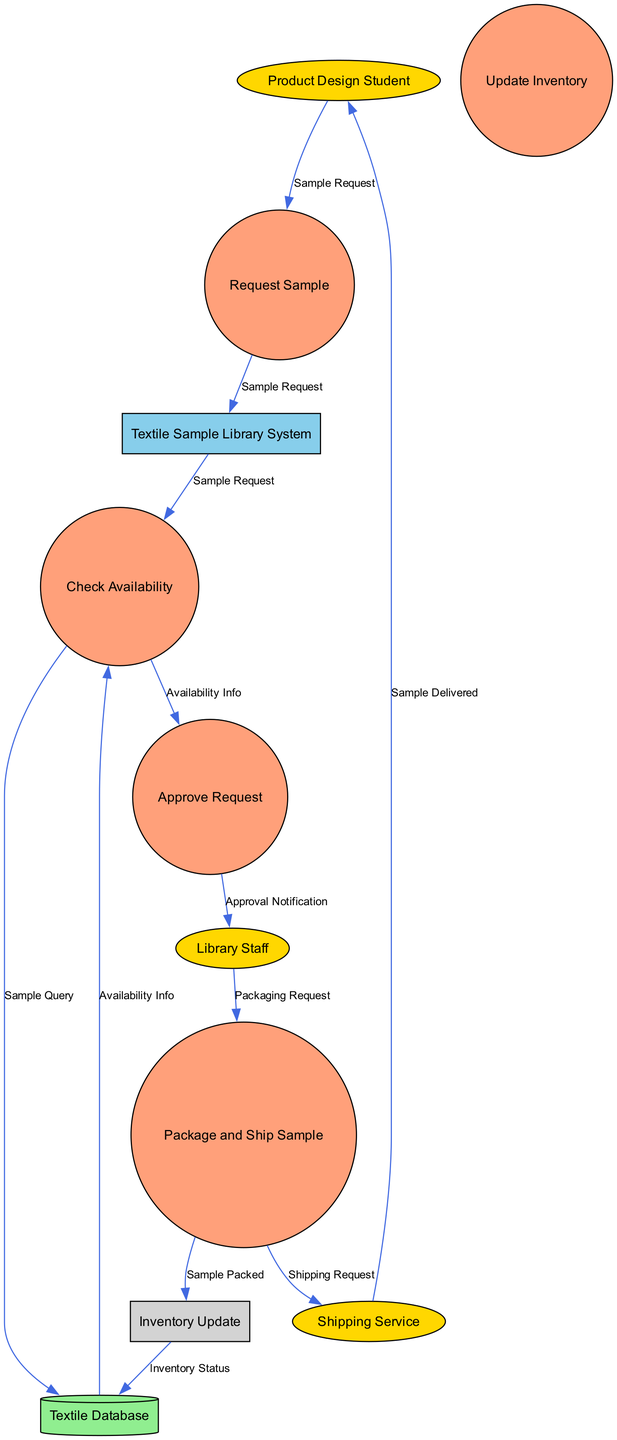What is the name of the system? The system representing the management and processing of textile samples is labeled as "Textile Sample Library System" in the diagram, indicating its main function.
Answer: Textile Sample Library System How many external entities are present in the diagram? The diagram identifies four external entities: "Product Design Student", "Library Staff", "Shipping Service", and the system itself does not count here. Thus, counting these entities gives a total of four.
Answer: 4 What process handles the approval of sample requests? The process responsible for approving sample requests is labeled as "Approve Request" within the diagram, reflecting its direct function in the workflow.
Answer: Approve Request What is the destination of the data flow labeled "Shipping Request"? The "Shipping Request" data flow originates from the "Package and Ship Sample" process and is directed towards the "Shipping Service", indicating where the shipping details are sent.
Answer: Shipping Service Which process updates the inventory? The "Update Inventory" process is specifically noted for managing and adjusting the inventory status following the processing of samples, positioning it as relevant to inventory management.
Answer: Update Inventory What data does the "Check Availability" process send to the "Textile Database"? The "Check Availability" process sends a "Sample Query" to the "Textile Database" to ascertain whether the requested textile samples are in stock, highlighting the data exchange necessary for availability checks.
Answer: Sample Query What is the flow of data after receiving "Availability Info"? Following the receipt of "Availability Info", the data is forwarded from "Check Availability" to "Approve Request", indicating that availability information leads to the approval of the sample request.
Answer: Approve Request Which external entity receives the data "Sample Delivered"? The data labeled "Sample Delivered" is sent from the "Shipping Service" to the "Product Design Student", marking the completion of the delivery process to the student.
Answer: Product Design Student What type of entity is the "Textile Database"? The "Textile Database" is classified as a "Data Store" within the diagram, designed to hold information relevant to the textile samples and their availability.
Answer: Data Store 